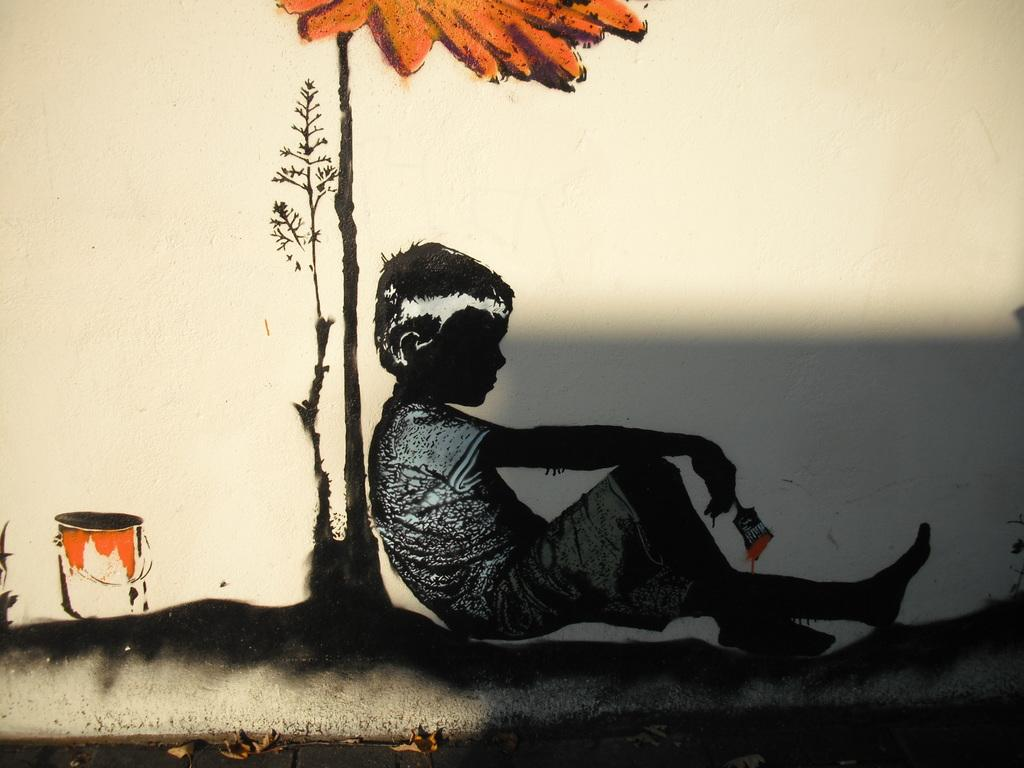What is the main subject of the painting in the image? The painting depicts a kid sitting and holding a paintbrush. What can be seen behind the kid in the painting? There is a plant behind the kid in the painting. What object is present near the kid in the painting? There is a bucket in the painting. What type of crown is the kid wearing in the painting? There is no crown present in the painting; the kid is holding a paintbrush. 